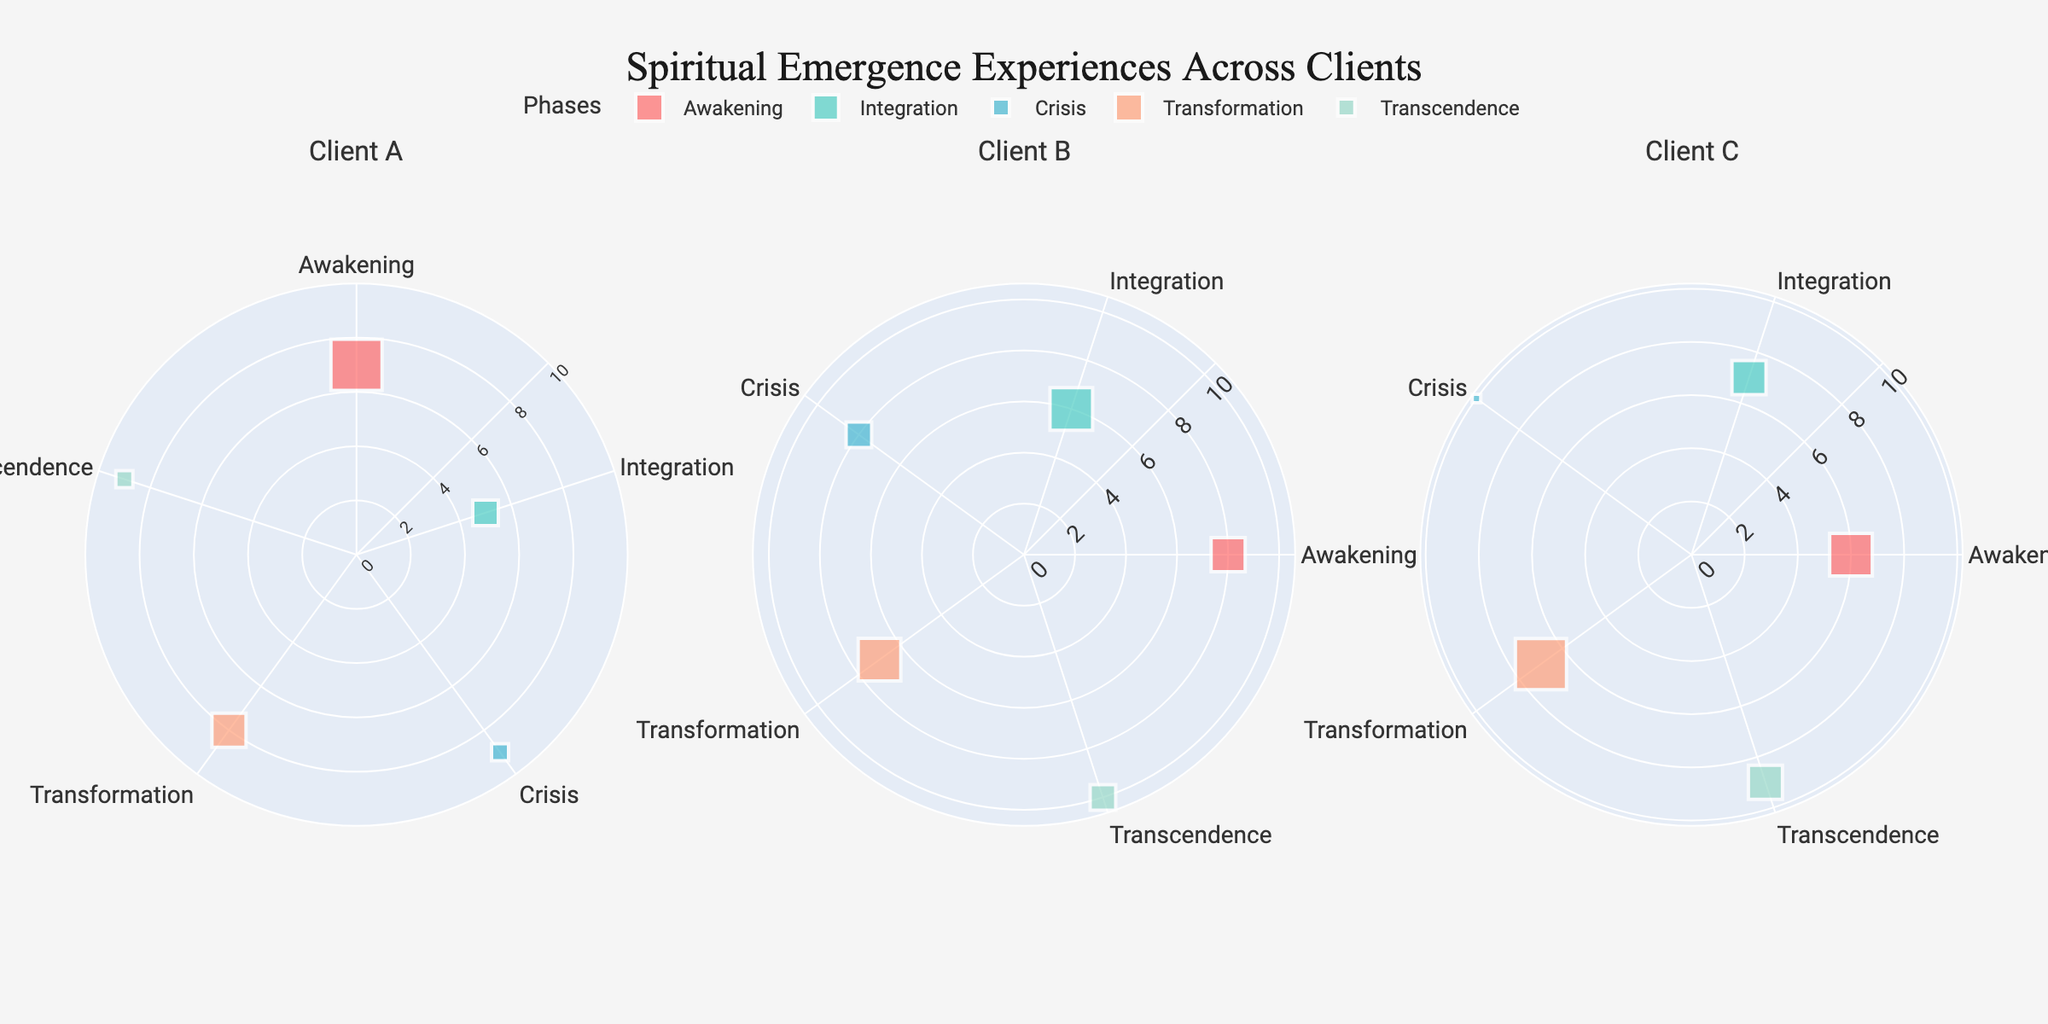What's the title of the figure? The title of the figure is usually displayed prominently above the plot, giving a summary of what the figure represents. By looking at the top of the displayed figure, we can see the title "Spiritual Emergence Experiences Across Clients".
Answer: Spiritual Emergence Experiences Across Clients How many clients are displayed in the subplots? Each subplot typically represents one client, and the subplot titles indicate which client each section of the chart pertains to. By counting the subplot titles, we see there are three: Client A, Client B, and Client C.
Answer: Three What colors represent each phase in the figure? The figure uses distinct colors to represent each phase. By examining the legend, we can determine which colors are associated with each phase: Awakening is red, Integration is teal, Crisis is blue, Transformation is salmon, and Transcendence is mint.
Answer: Awakening: red, Integration: teal, Crisis: blue, Transformation: salmon, Transcendence: mint Which phase has the highest intensity for Client C? Each scatterpolar plot shows different intensities for the phases. By looking at the 'Client C' subplot and comparing the radial distances of the points, we see that the Crisis phase has the highest intensity, shown by the highest radial value of 10.
Answer: Crisis What is the average intensity for the Transcendence phase across all clients? To find the average intensity, we need to add the intensities for each client during the Transcendence phase and divide by the number of clients. The intensities are 9 for Client A, 10 for Client B, and 9 for Client C. (9 + 10 + 9) / 3 = 28 / 3 = 9.33
Answer: 9.33 Which client has the shortest duration in the Transformation phase? The size of the markers indicates the duration of each phase. By comparing the sizes of the markers in the Transformation phase subplot for Clients A, B, and C, we see that Client A (4 months) has the smallest marker, smallest duration.
Answer: Client A What is the total duration for the Integration phase for Client B? For Client B's subplot, we look at the Integration phase and find the duration values. There is only one value, 5 months, and thus the total duration is 5 months.
Answer: 5 months Compare the intensities between the Awakening phase and the Transcendence phase for Client B. Which phase has a higher intensity? In the subplot for Client B, we look at the radial distances for both the Awakening and Transcendence phases. Awakening has an intensity of 8, while Transcendence has an intensity of 10. Therefore, Transcendence has a higher intensity.
Answer: Transcendence What is the longest duration experienced by Client A in any phase? By examining the subplot for Client A, we compare the marker sizes for each phase, which represent durations. The largest size corresponds to the Awakening phase with a duration of 6 months.
Answer: Awakening How does the Intensity level of Client C during Crisis compare to their Intensity level during Integration? In Client C's subplot, observe the radial values for Crisis and Integration phases. Crisis has an intensity of 10 and Integration has an intensity of 7. Crisis has a higher intensity than Integration.
Answer: Crisis 